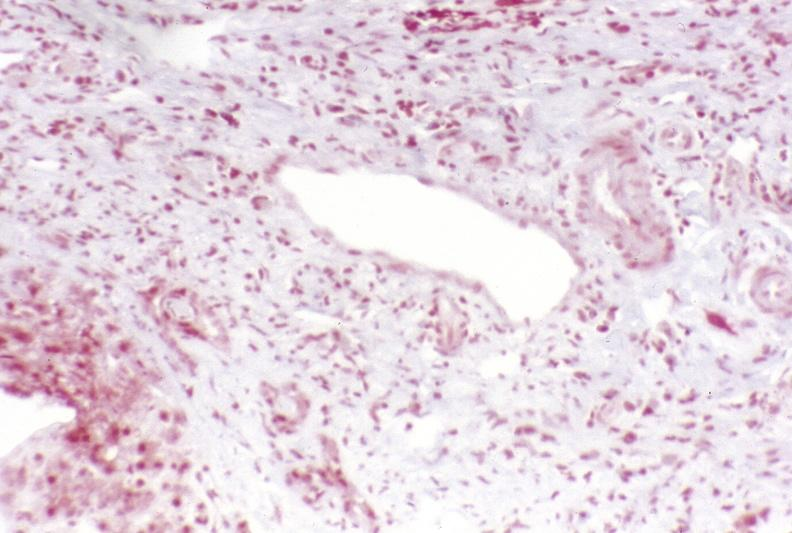s hepatobiliary present?
Answer the question using a single word or phrase. Yes 